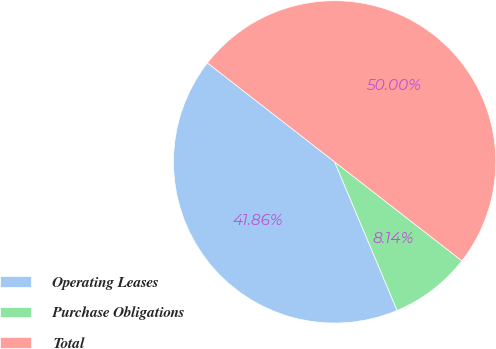<chart> <loc_0><loc_0><loc_500><loc_500><pie_chart><fcel>Operating Leases<fcel>Purchase Obligations<fcel>Total<nl><fcel>41.86%<fcel>8.14%<fcel>50.0%<nl></chart> 